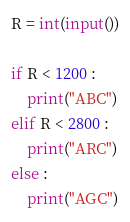Convert code to text. <code><loc_0><loc_0><loc_500><loc_500><_Python_>R = int(input())

if R < 1200 :
    print("ABC")
elif R < 2800 :
    print("ARC")
else :
    print("AGC")</code> 